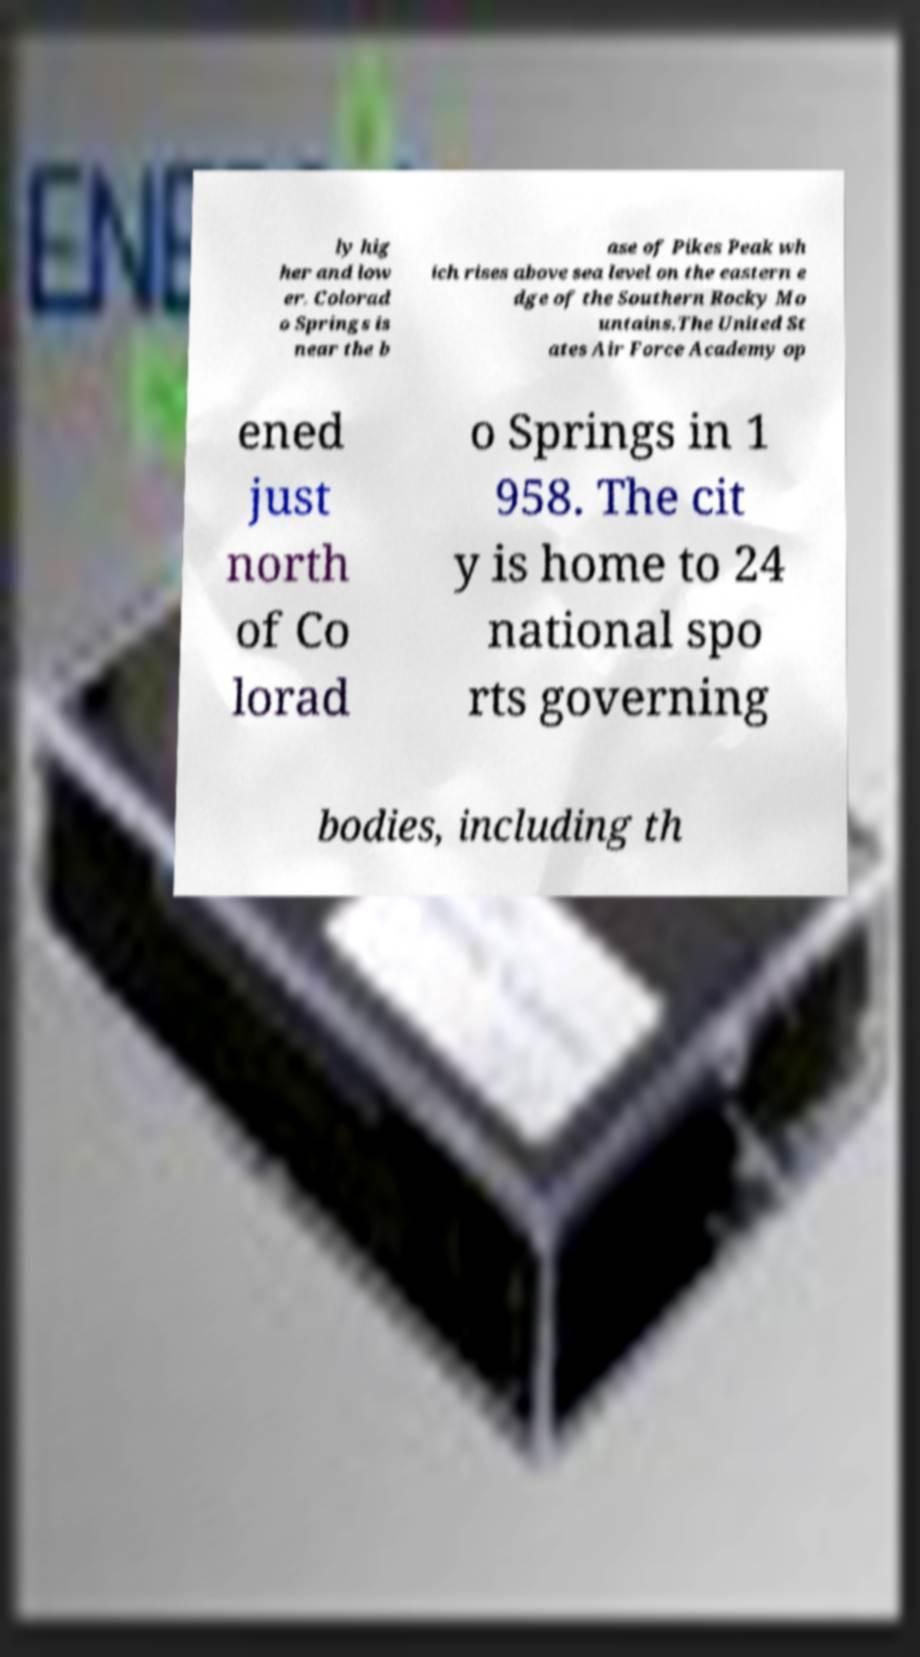Could you assist in decoding the text presented in this image and type it out clearly? ly hig her and low er. Colorad o Springs is near the b ase of Pikes Peak wh ich rises above sea level on the eastern e dge of the Southern Rocky Mo untains.The United St ates Air Force Academy op ened just north of Co lorad o Springs in 1 958. The cit y is home to 24 national spo rts governing bodies, including th 